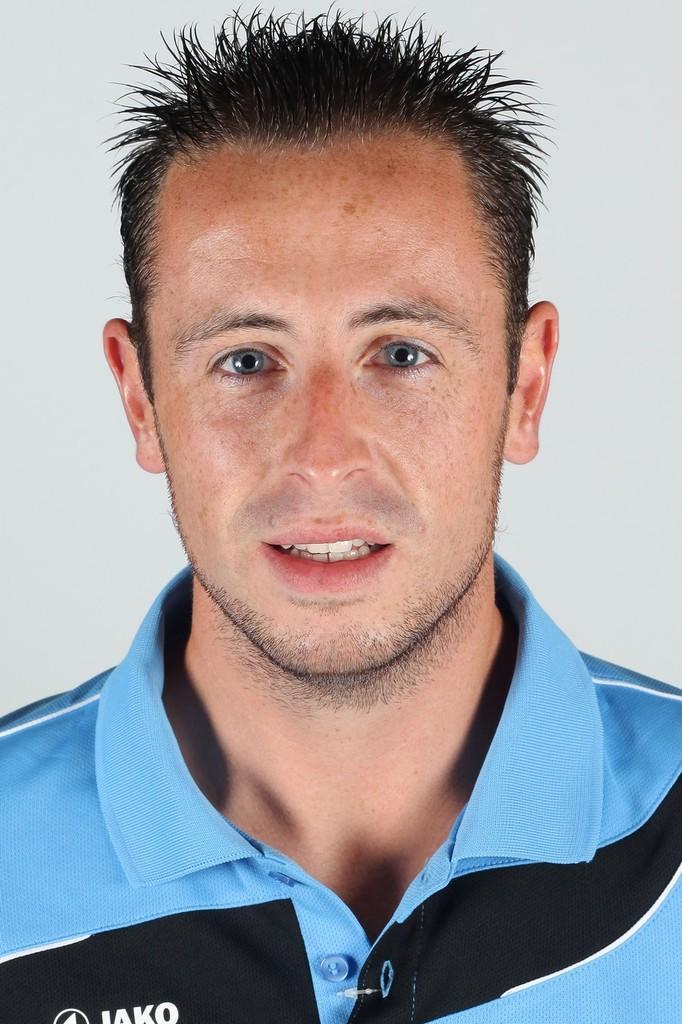Describe this image in one or two sentences. In this picture there is a man with blue and black t-shirt. At the back there is a off white background and there is text on the t-shirt. 